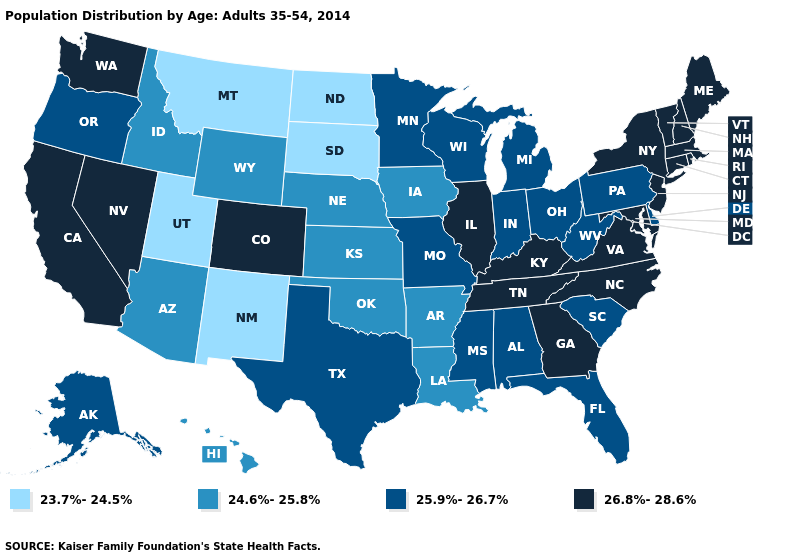Name the states that have a value in the range 25.9%-26.7%?
Write a very short answer. Alabama, Alaska, Delaware, Florida, Indiana, Michigan, Minnesota, Mississippi, Missouri, Ohio, Oregon, Pennsylvania, South Carolina, Texas, West Virginia, Wisconsin. What is the value of Idaho?
Concise answer only. 24.6%-25.8%. What is the value of Maine?
Answer briefly. 26.8%-28.6%. Among the states that border Colorado , which have the highest value?
Write a very short answer. Arizona, Kansas, Nebraska, Oklahoma, Wyoming. What is the value of Massachusetts?
Give a very brief answer. 26.8%-28.6%. What is the value of Mississippi?
Short answer required. 25.9%-26.7%. What is the value of Alaska?
Concise answer only. 25.9%-26.7%. Among the states that border Kansas , which have the lowest value?
Write a very short answer. Nebraska, Oklahoma. Which states have the highest value in the USA?
Quick response, please. California, Colorado, Connecticut, Georgia, Illinois, Kentucky, Maine, Maryland, Massachusetts, Nevada, New Hampshire, New Jersey, New York, North Carolina, Rhode Island, Tennessee, Vermont, Virginia, Washington. Does Florida have a higher value than Arizona?
Give a very brief answer. Yes. Which states have the lowest value in the Northeast?
Concise answer only. Pennsylvania. Among the states that border Florida , does Georgia have the lowest value?
Answer briefly. No. Does Louisiana have the lowest value in the USA?
Be succinct. No. Among the states that border Idaho , does Utah have the lowest value?
Short answer required. Yes. Name the states that have a value in the range 25.9%-26.7%?
Keep it brief. Alabama, Alaska, Delaware, Florida, Indiana, Michigan, Minnesota, Mississippi, Missouri, Ohio, Oregon, Pennsylvania, South Carolina, Texas, West Virginia, Wisconsin. 